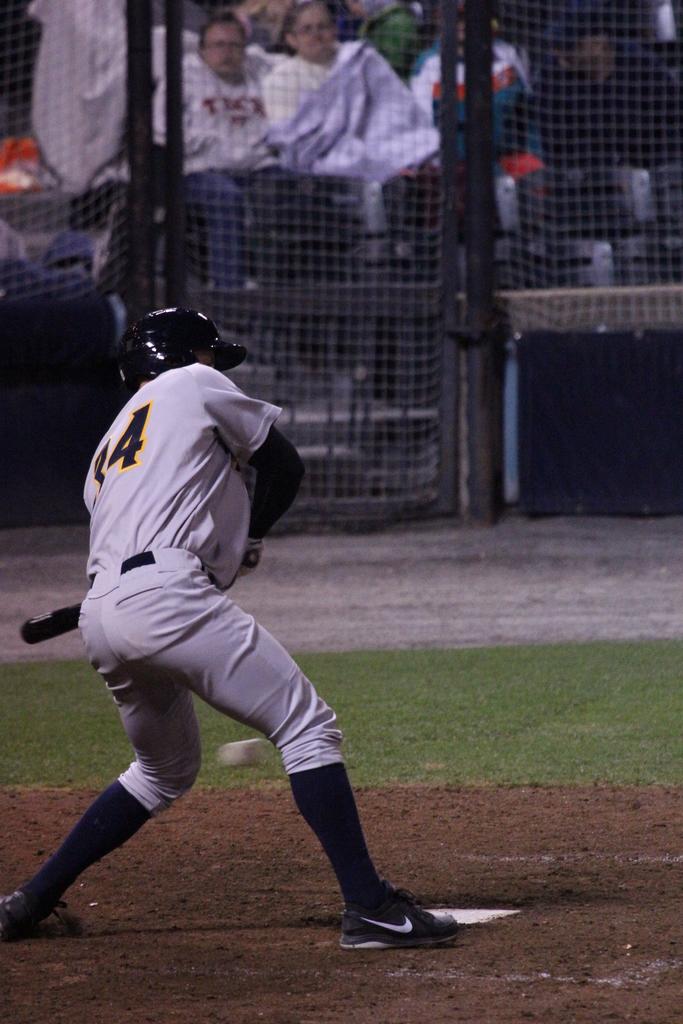What number is he?
Offer a terse response. 34. What games is this?
Keep it short and to the point. Baseball. 